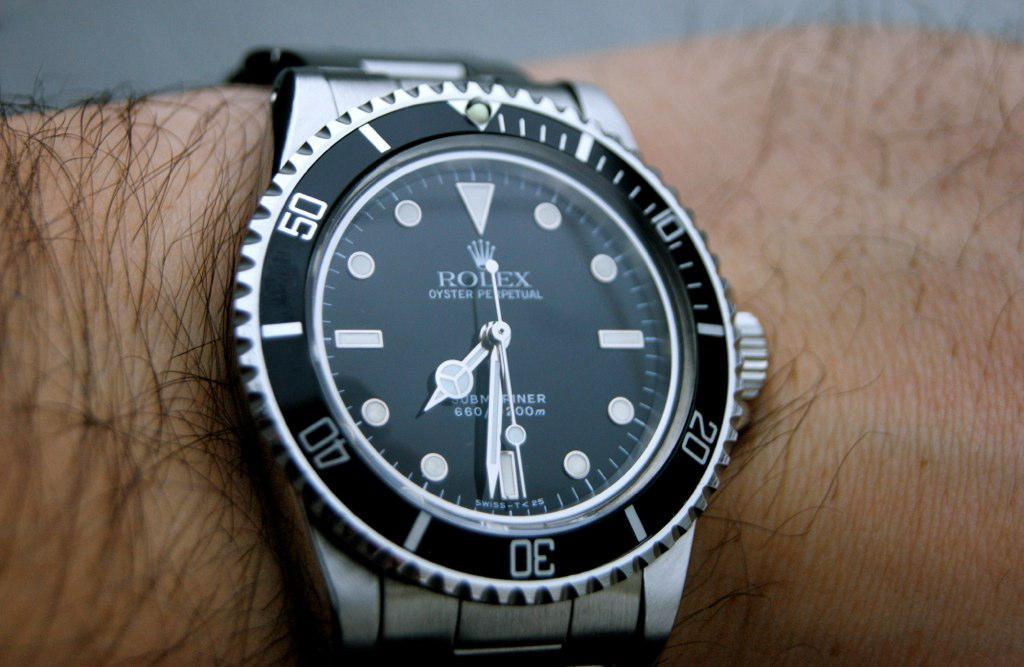<image>
Present a compact description of the photo's key features. A silver and black Rolex watch on somebody's wrist. 